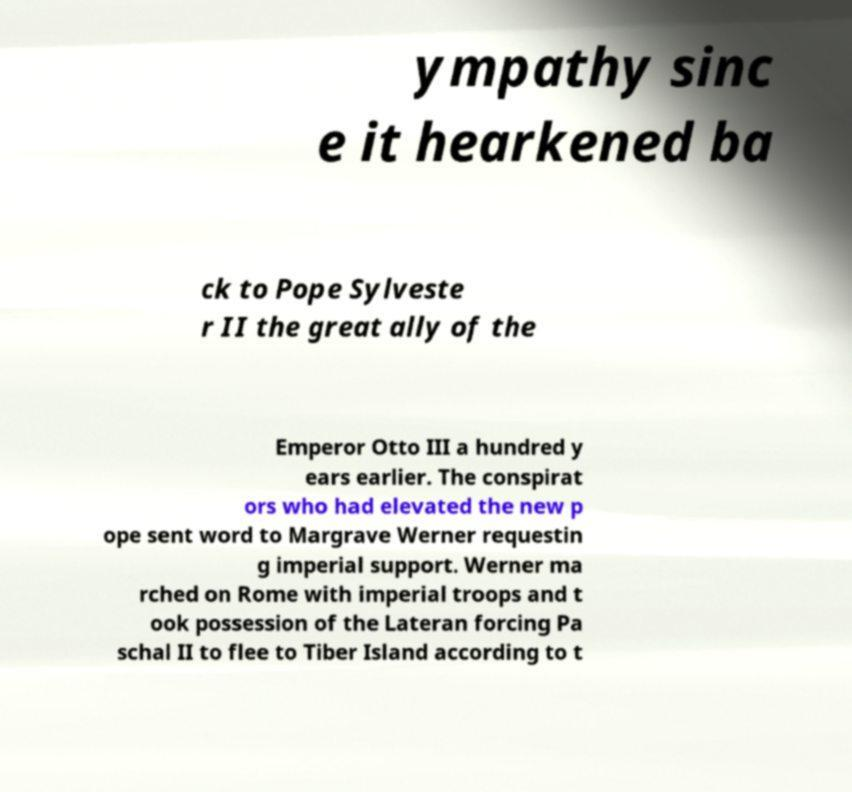Could you assist in decoding the text presented in this image and type it out clearly? ympathy sinc e it hearkened ba ck to Pope Sylveste r II the great ally of the Emperor Otto III a hundred y ears earlier. The conspirat ors who had elevated the new p ope sent word to Margrave Werner requestin g imperial support. Werner ma rched on Rome with imperial troops and t ook possession of the Lateran forcing Pa schal II to flee to Tiber Island according to t 